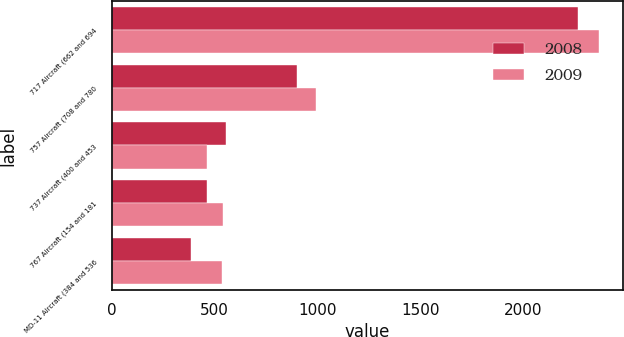Convert chart to OTSL. <chart><loc_0><loc_0><loc_500><loc_500><stacked_bar_chart><ecel><fcel>717 Aircraft (662 and 694<fcel>757 Aircraft (708 and 780<fcel>737 Aircraft (400 and 453<fcel>767 Aircraft (154 and 181<fcel>MD-11 Aircraft (384 and 536<nl><fcel>2008<fcel>2262<fcel>902<fcel>553<fcel>465<fcel>384<nl><fcel>2009<fcel>2365<fcel>991<fcel>464<fcel>540<fcel>536<nl></chart> 